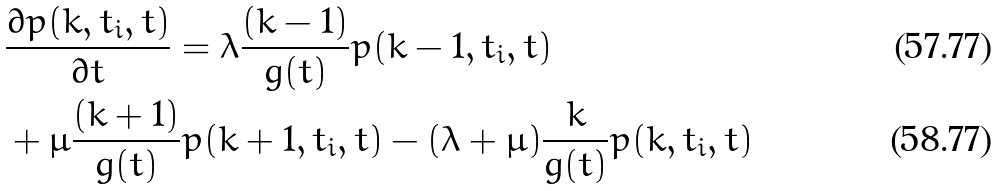<formula> <loc_0><loc_0><loc_500><loc_500>& \frac { \partial p ( k , t _ { i } , t ) } { \partial t } = \lambda \frac { ( k - 1 ) } { g ( t ) } p ( k - 1 , t _ { i } , t ) \\ & + \mu \frac { ( k + 1 ) } { g ( t ) } p ( k + 1 , t _ { i } , t ) - ( \lambda + \mu ) \frac { k } { g ( t ) } p ( k , t _ { i } , t )</formula> 